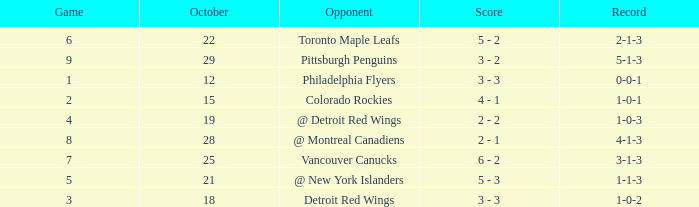Name the least game for record of 1-0-2 3.0. 